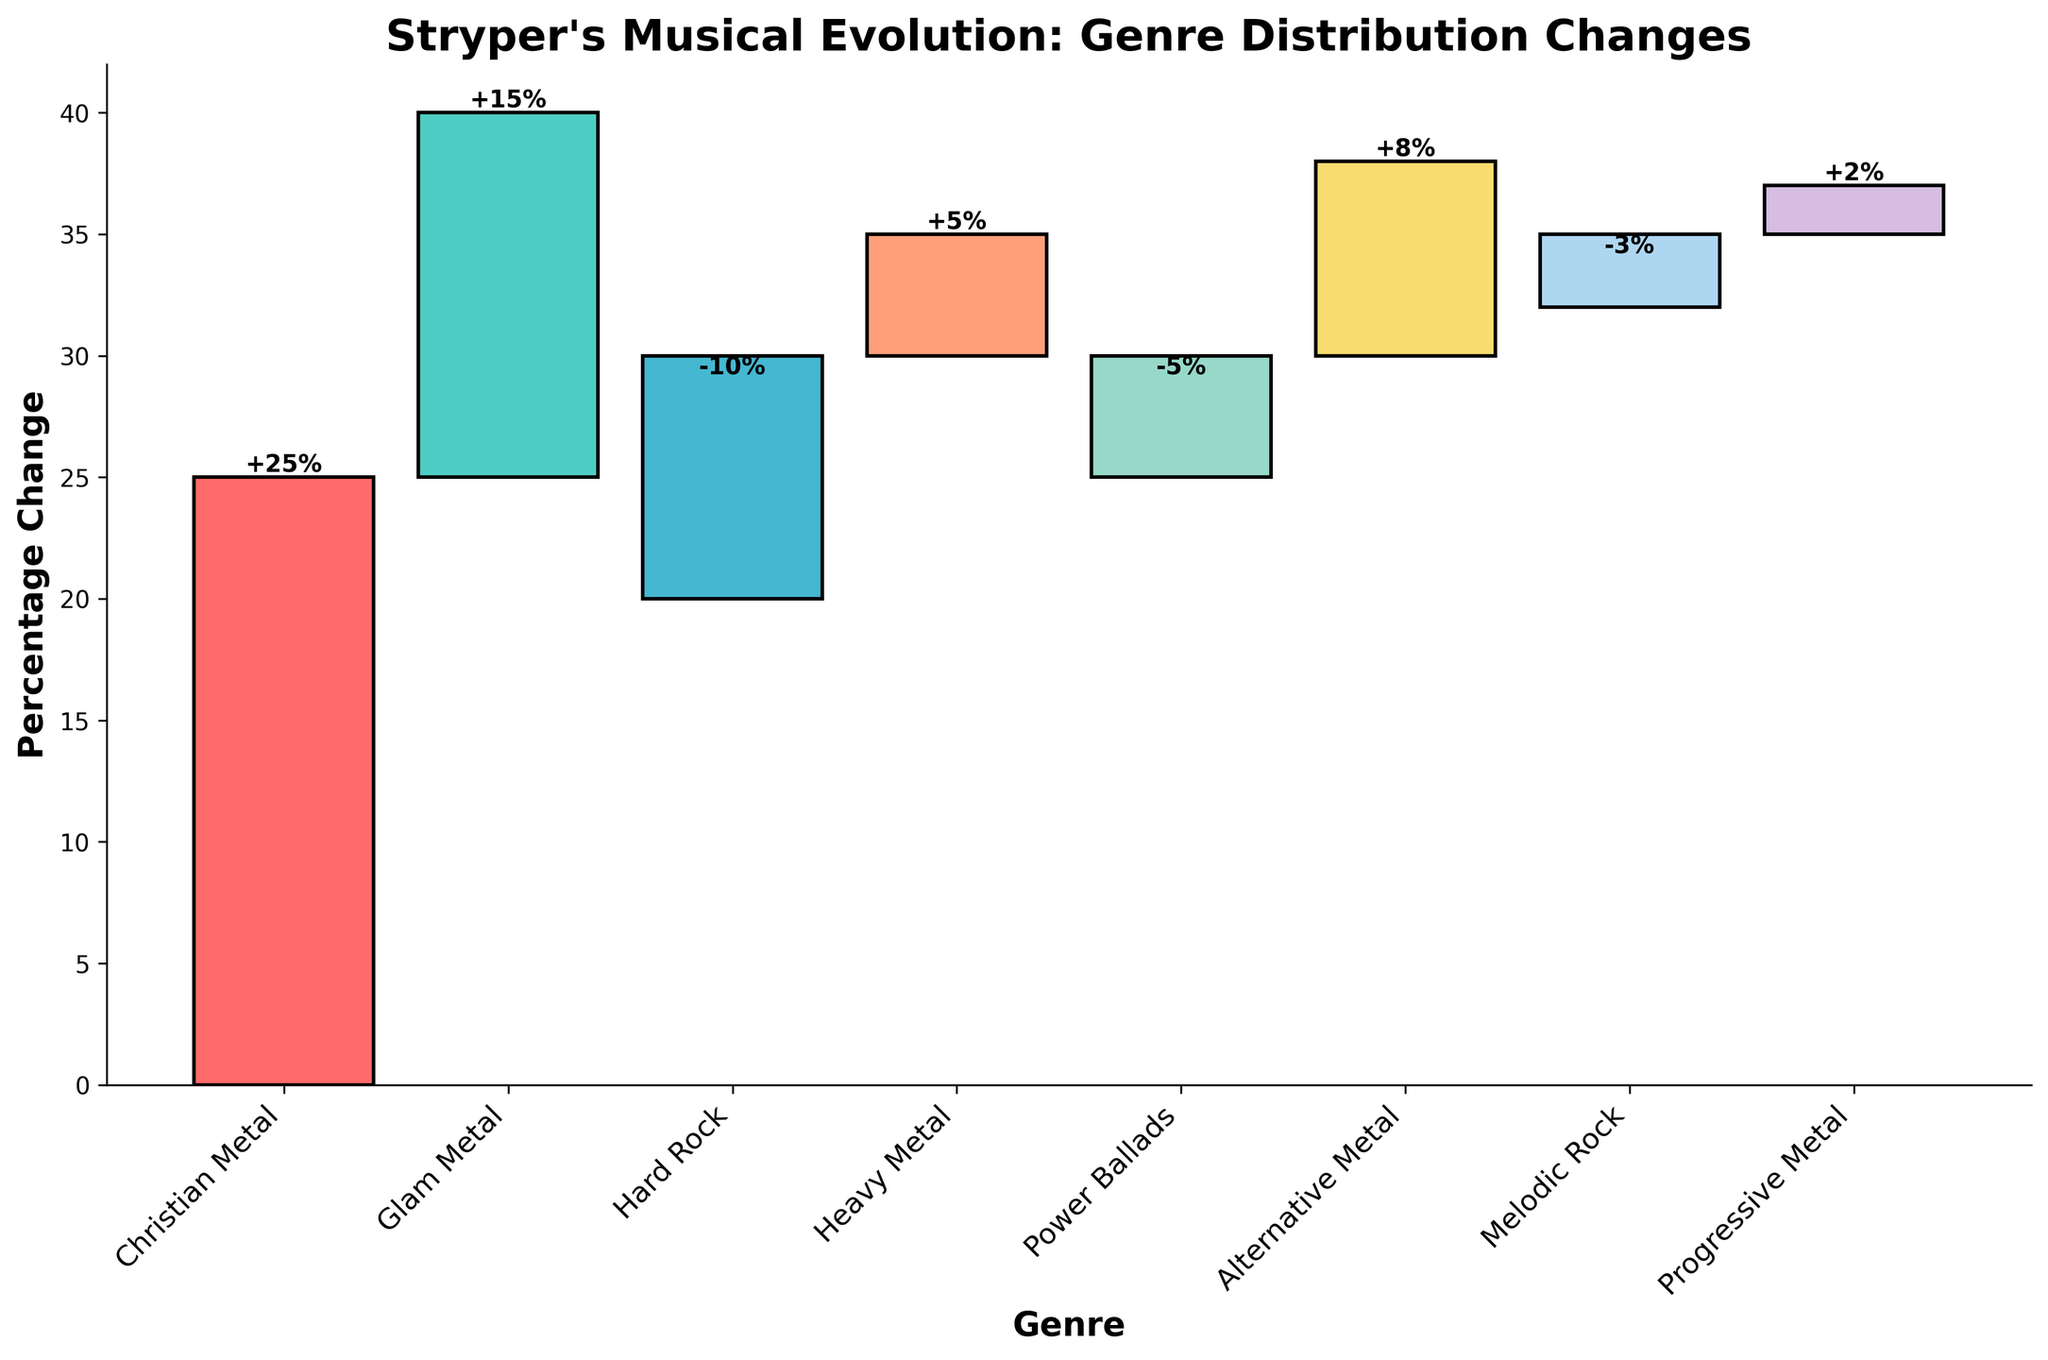How many genres are represented in the waterfall chart? Count the number of different genres listed on the x-axis.
Answer: 8 What is the title of the chart? Look at the title provided at the top of the chart.
Answer: Stryper's Musical Evolution: Genre Distribution Changes Which genre has the highest positive percentage change? Identify the genre with the tallest bar above the horizontal axis.
Answer: Christian Metal Which genre has the smallest change in percentage? Identify the genre with the bar closest to the horizontal axis, both above and below.
Answer: Progressive Metal What is the overall direction of change in Christian Metal? Observe the bar for Christian Metal; it is above the horizontal line.
Answer: Positive How would you describe the change in Hard Rock? Check the direction and height of the bar for Hard Rock; it is below the horizontal line.
Answer: Negative How many genres demonstrate a negative percentage change? Count the bars below the horizontal line.
Answer: 3 What is the sum of the percentage changes for Glam Metal and Heavy Metal? Add the percentage changes for Glam Metal (15) and Heavy Metal (5).
Answer: 20 Compare the percentage changes between Hard Rock and Melodic Rock. Which one is more negative? Look at the bars for Hard Rock (-10) and Melodic Rock (-3), and identify which has a greater negative value.
Answer: Hard Rock What is the cumulative percentage change after including Alternative Metal? Cumulative changes sum up sequentially; Alternative Metal is after Power Ballads (-5) and adds 8 to previous total 30, so 30 + 8.
Answer: 38 